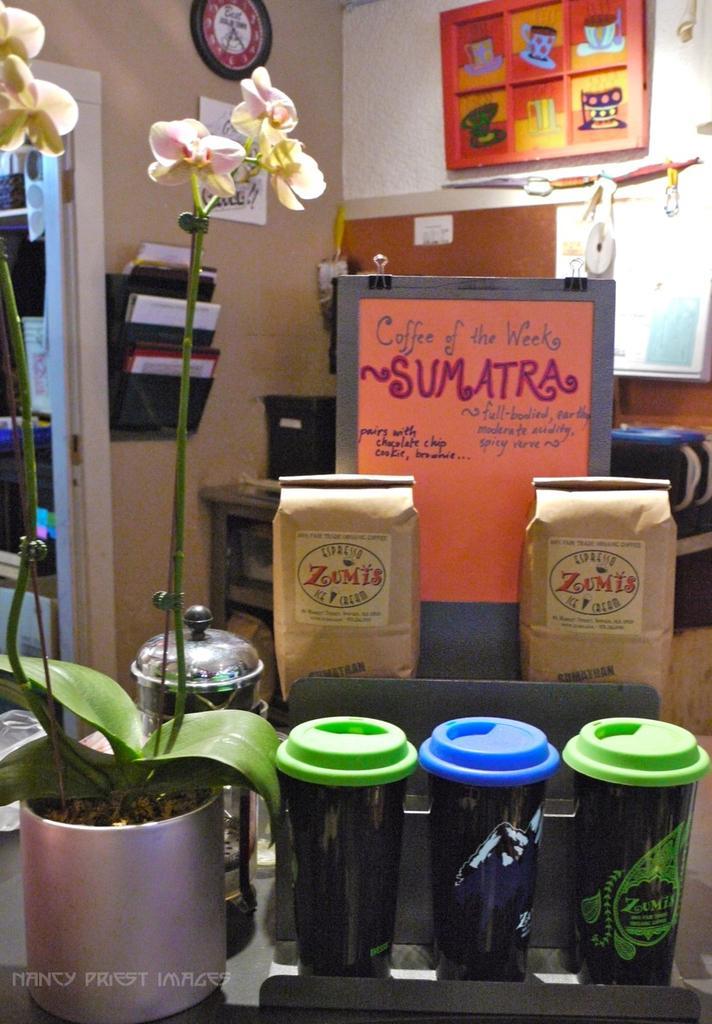Could you give a brief overview of what you see in this image? In the picture we can see a desk with a plant and long stem with flowers to it and beside it, we can see three things which are black in color and behind it, we can see two coffee packets and a board with some information about the coffee and in the background, we can see a wall with the clock, some posters and a board with some posters on it and beside the wall we can see another room door frame. 